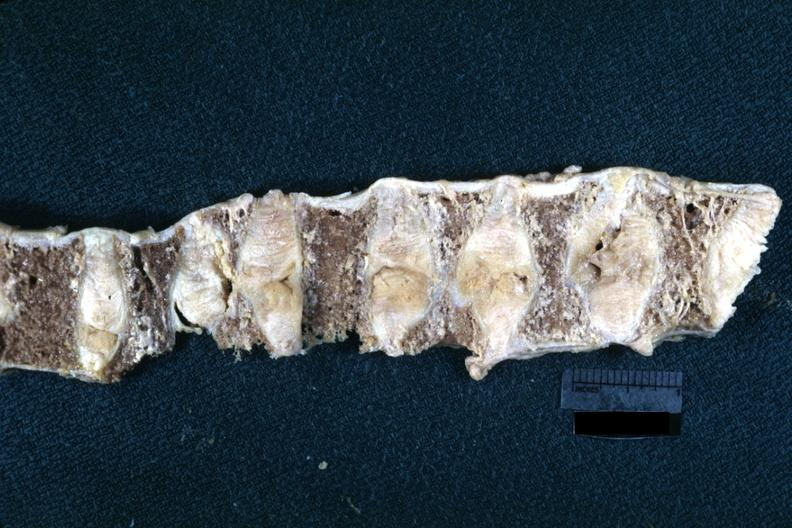s this lesion probably due to osteoporosis?
Answer the question using a single word or phrase. Yes 